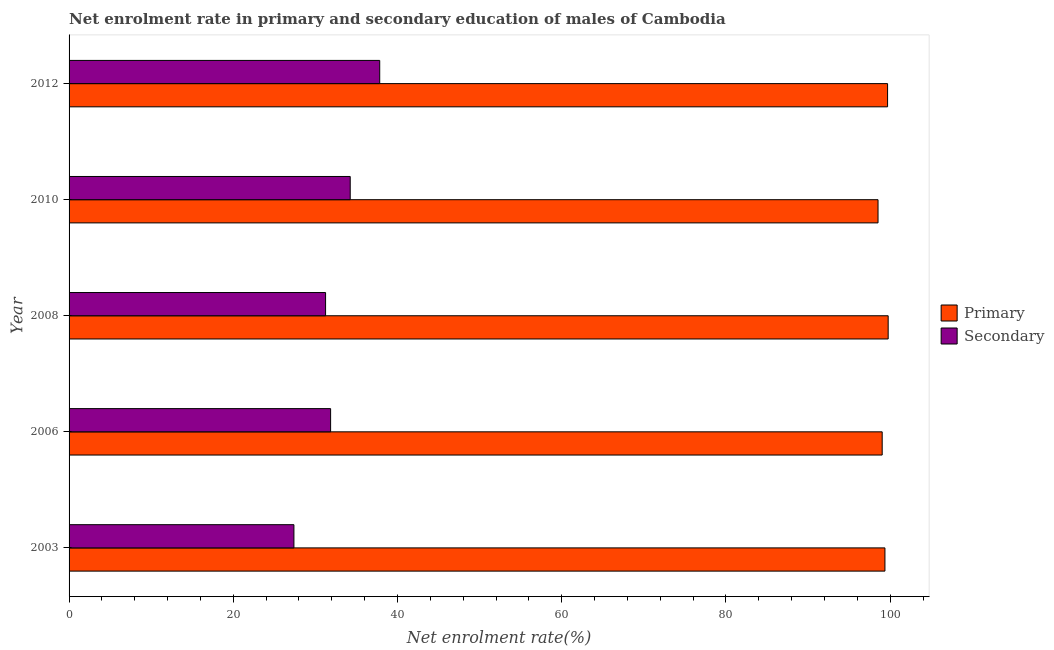How many different coloured bars are there?
Provide a short and direct response. 2. How many groups of bars are there?
Ensure brevity in your answer.  5. Are the number of bars per tick equal to the number of legend labels?
Provide a short and direct response. Yes. How many bars are there on the 2nd tick from the top?
Your answer should be very brief. 2. How many bars are there on the 1st tick from the bottom?
Your answer should be compact. 2. In how many cases, is the number of bars for a given year not equal to the number of legend labels?
Offer a terse response. 0. What is the enrollment rate in primary education in 2003?
Give a very brief answer. 99.36. Across all years, what is the maximum enrollment rate in secondary education?
Provide a short and direct response. 37.83. Across all years, what is the minimum enrollment rate in secondary education?
Your answer should be compact. 27.38. In which year was the enrollment rate in primary education maximum?
Make the answer very short. 2008. In which year was the enrollment rate in secondary education minimum?
Offer a terse response. 2003. What is the total enrollment rate in secondary education in the graph?
Keep it short and to the point. 162.54. What is the difference between the enrollment rate in primary education in 2003 and that in 2010?
Your response must be concise. 0.84. What is the difference between the enrollment rate in secondary education in 2012 and the enrollment rate in primary education in 2010?
Offer a terse response. -60.69. What is the average enrollment rate in primary education per year?
Ensure brevity in your answer.  99.27. In the year 2006, what is the difference between the enrollment rate in secondary education and enrollment rate in primary education?
Offer a very short reply. -67.17. In how many years, is the enrollment rate in secondary education greater than 88 %?
Provide a short and direct response. 0. What is the ratio of the enrollment rate in primary education in 2006 to that in 2008?
Offer a very short reply. 0.99. What is the difference between the highest and the second highest enrollment rate in secondary education?
Provide a succinct answer. 3.59. What is the difference between the highest and the lowest enrollment rate in primary education?
Offer a terse response. 1.24. What does the 1st bar from the top in 2012 represents?
Provide a succinct answer. Secondary. What does the 1st bar from the bottom in 2003 represents?
Your response must be concise. Primary. How many bars are there?
Your response must be concise. 10. Are all the bars in the graph horizontal?
Make the answer very short. Yes. How many years are there in the graph?
Your answer should be compact. 5. Does the graph contain any zero values?
Your answer should be compact. No. How are the legend labels stacked?
Your answer should be very brief. Vertical. What is the title of the graph?
Make the answer very short. Net enrolment rate in primary and secondary education of males of Cambodia. What is the label or title of the X-axis?
Provide a short and direct response. Net enrolment rate(%). What is the label or title of the Y-axis?
Provide a short and direct response. Year. What is the Net enrolment rate(%) of Primary in 2003?
Keep it short and to the point. 99.36. What is the Net enrolment rate(%) of Secondary in 2003?
Make the answer very short. 27.38. What is the Net enrolment rate(%) of Primary in 2006?
Ensure brevity in your answer.  99.02. What is the Net enrolment rate(%) of Secondary in 2006?
Offer a terse response. 31.85. What is the Net enrolment rate(%) of Primary in 2008?
Make the answer very short. 99.75. What is the Net enrolment rate(%) of Secondary in 2008?
Provide a short and direct response. 31.24. What is the Net enrolment rate(%) in Primary in 2010?
Ensure brevity in your answer.  98.52. What is the Net enrolment rate(%) of Secondary in 2010?
Offer a terse response. 34.24. What is the Net enrolment rate(%) of Primary in 2012?
Offer a terse response. 99.68. What is the Net enrolment rate(%) in Secondary in 2012?
Ensure brevity in your answer.  37.83. Across all years, what is the maximum Net enrolment rate(%) in Primary?
Provide a short and direct response. 99.75. Across all years, what is the maximum Net enrolment rate(%) of Secondary?
Offer a terse response. 37.83. Across all years, what is the minimum Net enrolment rate(%) in Primary?
Keep it short and to the point. 98.52. Across all years, what is the minimum Net enrolment rate(%) of Secondary?
Your response must be concise. 27.38. What is the total Net enrolment rate(%) of Primary in the graph?
Give a very brief answer. 496.33. What is the total Net enrolment rate(%) in Secondary in the graph?
Your response must be concise. 162.54. What is the difference between the Net enrolment rate(%) of Primary in 2003 and that in 2006?
Provide a succinct answer. 0.34. What is the difference between the Net enrolment rate(%) of Secondary in 2003 and that in 2006?
Make the answer very short. -4.47. What is the difference between the Net enrolment rate(%) of Primary in 2003 and that in 2008?
Provide a succinct answer. -0.39. What is the difference between the Net enrolment rate(%) of Secondary in 2003 and that in 2008?
Give a very brief answer. -3.86. What is the difference between the Net enrolment rate(%) of Primary in 2003 and that in 2010?
Make the answer very short. 0.84. What is the difference between the Net enrolment rate(%) in Secondary in 2003 and that in 2010?
Keep it short and to the point. -6.86. What is the difference between the Net enrolment rate(%) in Primary in 2003 and that in 2012?
Keep it short and to the point. -0.32. What is the difference between the Net enrolment rate(%) in Secondary in 2003 and that in 2012?
Keep it short and to the point. -10.45. What is the difference between the Net enrolment rate(%) in Primary in 2006 and that in 2008?
Make the answer very short. -0.73. What is the difference between the Net enrolment rate(%) of Secondary in 2006 and that in 2008?
Your response must be concise. 0.61. What is the difference between the Net enrolment rate(%) in Primary in 2006 and that in 2010?
Provide a short and direct response. 0.51. What is the difference between the Net enrolment rate(%) of Secondary in 2006 and that in 2010?
Give a very brief answer. -2.39. What is the difference between the Net enrolment rate(%) in Primary in 2006 and that in 2012?
Provide a succinct answer. -0.66. What is the difference between the Net enrolment rate(%) in Secondary in 2006 and that in 2012?
Provide a short and direct response. -5.98. What is the difference between the Net enrolment rate(%) in Primary in 2008 and that in 2010?
Your response must be concise. 1.24. What is the difference between the Net enrolment rate(%) of Secondary in 2008 and that in 2010?
Provide a succinct answer. -3. What is the difference between the Net enrolment rate(%) of Primary in 2008 and that in 2012?
Provide a succinct answer. 0.07. What is the difference between the Net enrolment rate(%) of Secondary in 2008 and that in 2012?
Keep it short and to the point. -6.59. What is the difference between the Net enrolment rate(%) in Primary in 2010 and that in 2012?
Provide a short and direct response. -1.16. What is the difference between the Net enrolment rate(%) of Secondary in 2010 and that in 2012?
Provide a short and direct response. -3.59. What is the difference between the Net enrolment rate(%) in Primary in 2003 and the Net enrolment rate(%) in Secondary in 2006?
Keep it short and to the point. 67.51. What is the difference between the Net enrolment rate(%) in Primary in 2003 and the Net enrolment rate(%) in Secondary in 2008?
Your answer should be very brief. 68.12. What is the difference between the Net enrolment rate(%) in Primary in 2003 and the Net enrolment rate(%) in Secondary in 2010?
Provide a succinct answer. 65.12. What is the difference between the Net enrolment rate(%) in Primary in 2003 and the Net enrolment rate(%) in Secondary in 2012?
Your response must be concise. 61.53. What is the difference between the Net enrolment rate(%) of Primary in 2006 and the Net enrolment rate(%) of Secondary in 2008?
Provide a succinct answer. 67.78. What is the difference between the Net enrolment rate(%) in Primary in 2006 and the Net enrolment rate(%) in Secondary in 2010?
Your answer should be very brief. 64.78. What is the difference between the Net enrolment rate(%) of Primary in 2006 and the Net enrolment rate(%) of Secondary in 2012?
Provide a short and direct response. 61.19. What is the difference between the Net enrolment rate(%) in Primary in 2008 and the Net enrolment rate(%) in Secondary in 2010?
Offer a terse response. 65.51. What is the difference between the Net enrolment rate(%) of Primary in 2008 and the Net enrolment rate(%) of Secondary in 2012?
Ensure brevity in your answer.  61.92. What is the difference between the Net enrolment rate(%) of Primary in 2010 and the Net enrolment rate(%) of Secondary in 2012?
Your answer should be very brief. 60.69. What is the average Net enrolment rate(%) in Primary per year?
Offer a terse response. 99.27. What is the average Net enrolment rate(%) in Secondary per year?
Keep it short and to the point. 32.51. In the year 2003, what is the difference between the Net enrolment rate(%) in Primary and Net enrolment rate(%) in Secondary?
Provide a succinct answer. 71.98. In the year 2006, what is the difference between the Net enrolment rate(%) in Primary and Net enrolment rate(%) in Secondary?
Offer a very short reply. 67.17. In the year 2008, what is the difference between the Net enrolment rate(%) of Primary and Net enrolment rate(%) of Secondary?
Provide a short and direct response. 68.51. In the year 2010, what is the difference between the Net enrolment rate(%) in Primary and Net enrolment rate(%) in Secondary?
Keep it short and to the point. 64.28. In the year 2012, what is the difference between the Net enrolment rate(%) of Primary and Net enrolment rate(%) of Secondary?
Your answer should be very brief. 61.85. What is the ratio of the Net enrolment rate(%) of Secondary in 2003 to that in 2006?
Provide a succinct answer. 0.86. What is the ratio of the Net enrolment rate(%) of Primary in 2003 to that in 2008?
Ensure brevity in your answer.  1. What is the ratio of the Net enrolment rate(%) of Secondary in 2003 to that in 2008?
Keep it short and to the point. 0.88. What is the ratio of the Net enrolment rate(%) of Primary in 2003 to that in 2010?
Keep it short and to the point. 1.01. What is the ratio of the Net enrolment rate(%) in Secondary in 2003 to that in 2010?
Offer a very short reply. 0.8. What is the ratio of the Net enrolment rate(%) of Primary in 2003 to that in 2012?
Your answer should be very brief. 1. What is the ratio of the Net enrolment rate(%) of Secondary in 2003 to that in 2012?
Your answer should be very brief. 0.72. What is the ratio of the Net enrolment rate(%) in Secondary in 2006 to that in 2008?
Make the answer very short. 1.02. What is the ratio of the Net enrolment rate(%) in Primary in 2006 to that in 2010?
Provide a short and direct response. 1.01. What is the ratio of the Net enrolment rate(%) in Secondary in 2006 to that in 2010?
Make the answer very short. 0.93. What is the ratio of the Net enrolment rate(%) of Primary in 2006 to that in 2012?
Your answer should be very brief. 0.99. What is the ratio of the Net enrolment rate(%) of Secondary in 2006 to that in 2012?
Give a very brief answer. 0.84. What is the ratio of the Net enrolment rate(%) of Primary in 2008 to that in 2010?
Your response must be concise. 1.01. What is the ratio of the Net enrolment rate(%) in Secondary in 2008 to that in 2010?
Give a very brief answer. 0.91. What is the ratio of the Net enrolment rate(%) in Secondary in 2008 to that in 2012?
Your answer should be compact. 0.83. What is the ratio of the Net enrolment rate(%) in Primary in 2010 to that in 2012?
Offer a terse response. 0.99. What is the ratio of the Net enrolment rate(%) in Secondary in 2010 to that in 2012?
Keep it short and to the point. 0.91. What is the difference between the highest and the second highest Net enrolment rate(%) in Primary?
Your response must be concise. 0.07. What is the difference between the highest and the second highest Net enrolment rate(%) of Secondary?
Keep it short and to the point. 3.59. What is the difference between the highest and the lowest Net enrolment rate(%) of Primary?
Your answer should be compact. 1.24. What is the difference between the highest and the lowest Net enrolment rate(%) of Secondary?
Offer a very short reply. 10.45. 